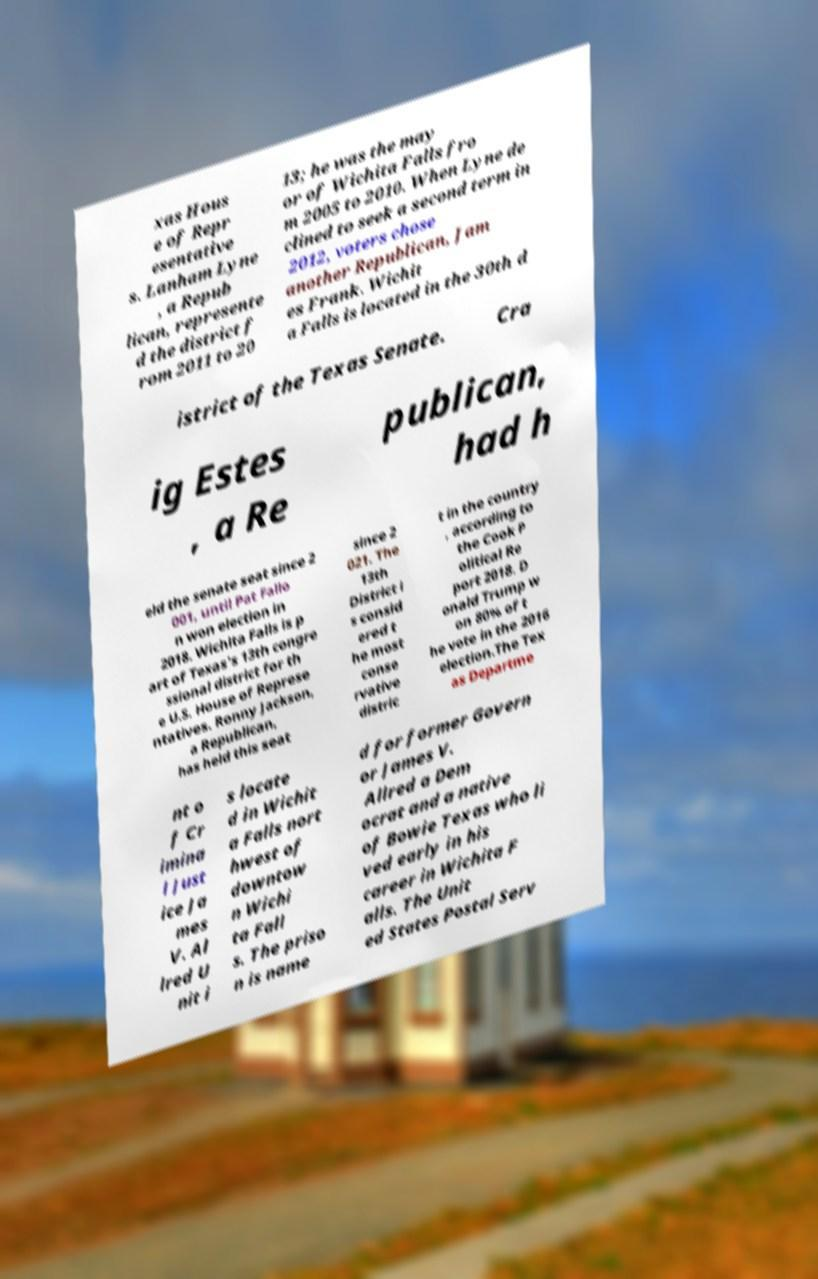Can you read and provide the text displayed in the image?This photo seems to have some interesting text. Can you extract and type it out for me? xas Hous e of Repr esentative s. Lanham Lyne , a Repub lican, represente d the district f rom 2011 to 20 13; he was the may or of Wichita Falls fro m 2005 to 2010. When Lyne de clined to seek a second term in 2012, voters chose another Republican, Jam es Frank. Wichit a Falls is located in the 30th d istrict of the Texas Senate. Cra ig Estes , a Re publican, had h eld the senate seat since 2 001, until Pat Fallo n won election in 2018. Wichita Falls is p art of Texas's 13th congre ssional district for th e U.S. House of Represe ntatives. Ronny Jackson, a Republican, has held this seat since 2 021. The 13th District i s consid ered t he most conse rvative distric t in the country , according to the Cook P olitical Re port 2018. D onald Trump w on 80% of t he vote in the 2016 election.The Tex as Departme nt o f Cr imina l Just ice Ja mes V. Al lred U nit i s locate d in Wichit a Falls nort hwest of downtow n Wichi ta Fall s. The priso n is name d for former Govern or James V. Allred a Dem ocrat and a native of Bowie Texas who li ved early in his career in Wichita F alls. The Unit ed States Postal Serv 